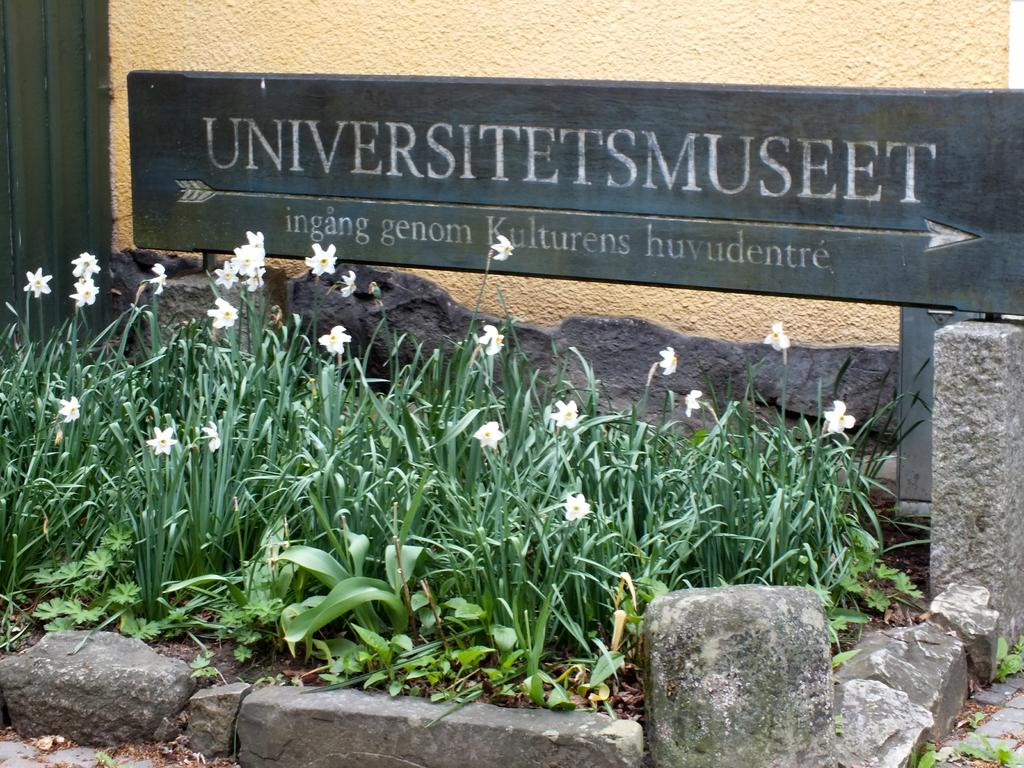What is the main object in the image? There is a name board in the image. What is located behind the name board? There is a wall in the image. What type of vegetation is present in the image? There are plants in the image. What type of natural element is also present in the image? There are rocks in the image. What is the result of adding 2 and 37 in the image? There is no addition or numerical values present in the image; it features a name board, a wall, plants, and rocks. Can you tell me how many goats are visible in the image? There are no goats present in the image. 